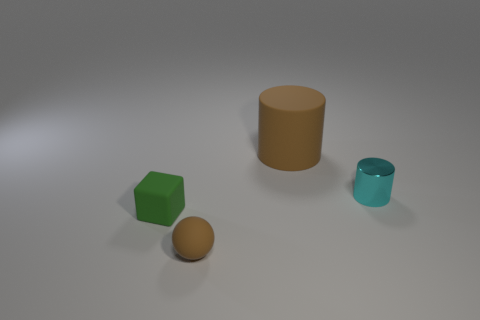Add 3 large yellow metal cylinders. How many objects exist? 7 Subtract all cubes. How many objects are left? 3 Subtract all big matte cylinders. Subtract all large objects. How many objects are left? 2 Add 2 shiny objects. How many shiny objects are left? 3 Add 3 big brown things. How many big brown things exist? 4 Subtract 0 cyan cubes. How many objects are left? 4 